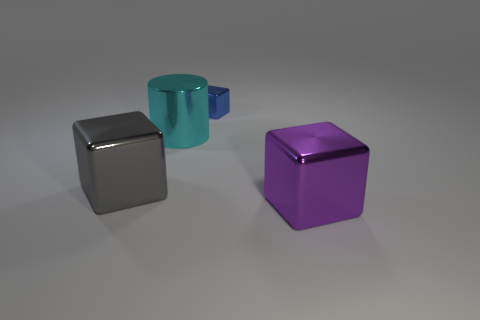Add 4 big cyan shiny things. How many objects exist? 8 Subtract all cubes. How many objects are left? 1 Add 1 tiny blue things. How many tiny blue things exist? 2 Subtract 0 purple balls. How many objects are left? 4 Subtract all large things. Subtract all large cylinders. How many objects are left? 0 Add 1 blue cubes. How many blue cubes are left? 2 